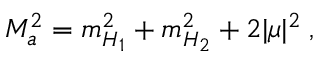<formula> <loc_0><loc_0><loc_500><loc_500>M _ { a } ^ { 2 } = m _ { H _ { 1 } } ^ { 2 } + m _ { H _ { 2 } } ^ { 2 } + 2 | \mu | ^ { 2 } \, ,</formula> 